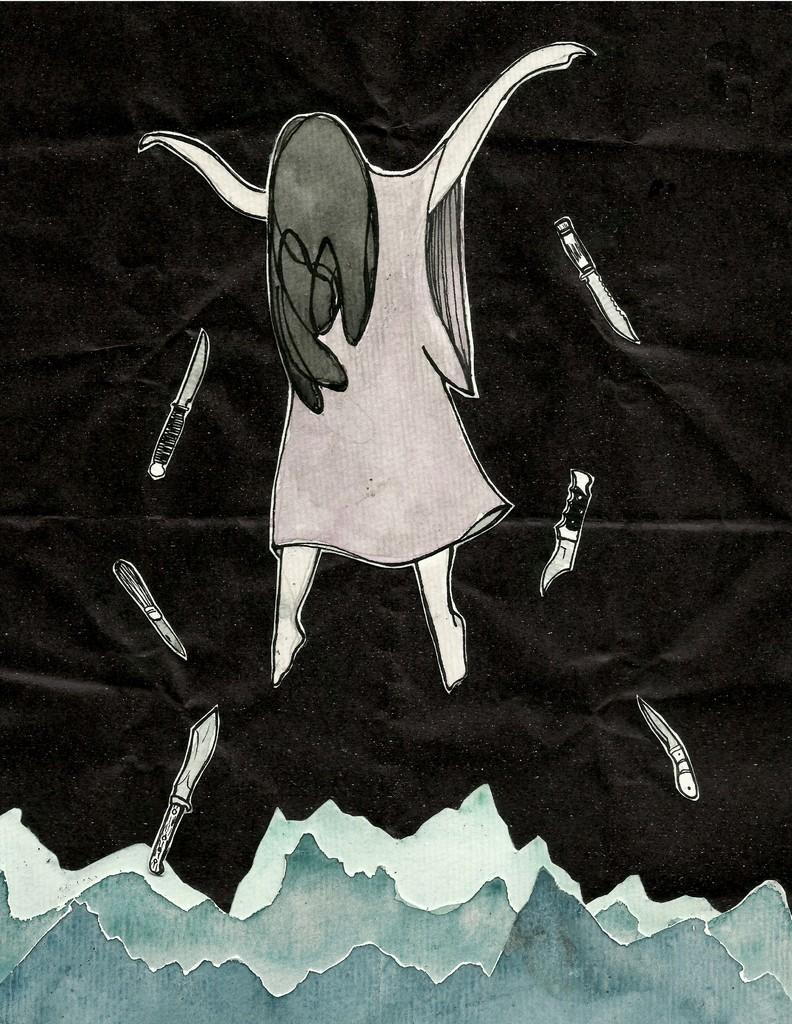What is the main subject in the center of the image? There is a graffiti in the center of the image. How does the graffiti provide shade in the image? The graffiti does not provide shade in the image, as it is a two-dimensional representation and cannot physically block sunlight. 